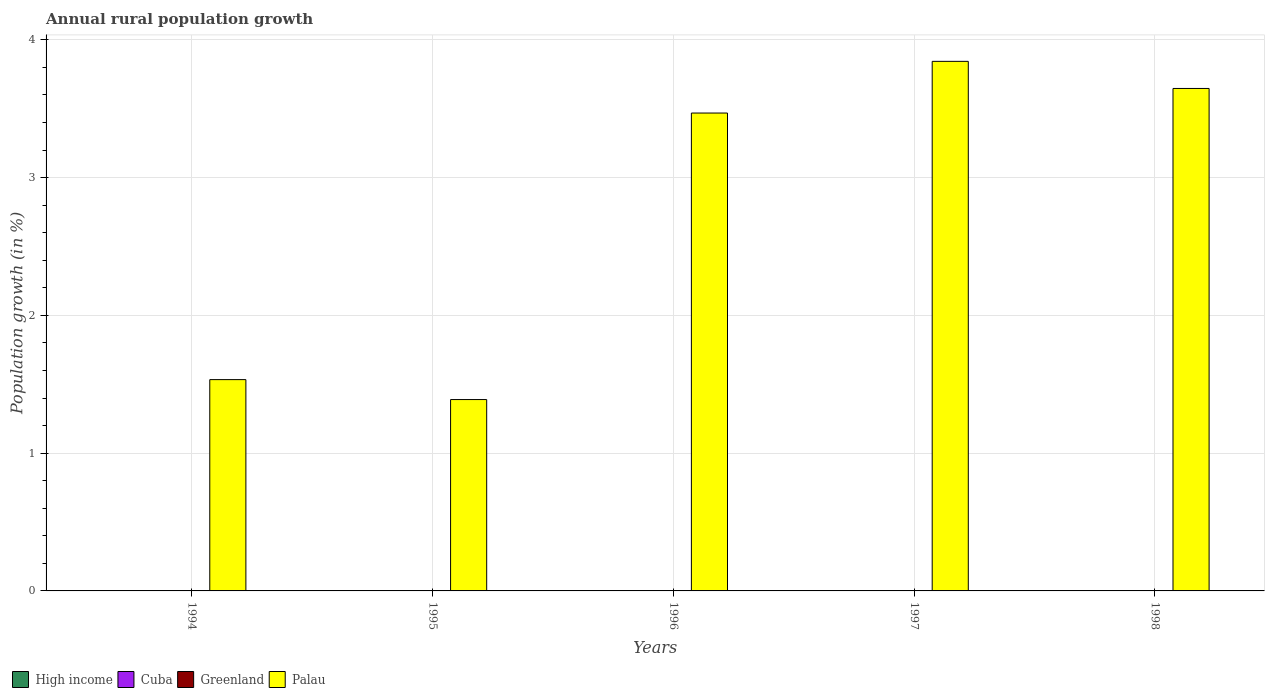How many different coloured bars are there?
Offer a terse response. 1. Are the number of bars on each tick of the X-axis equal?
Your response must be concise. Yes. How many bars are there on the 5th tick from the left?
Your answer should be very brief. 1. How many bars are there on the 2nd tick from the right?
Keep it short and to the point. 1. In how many cases, is the number of bars for a given year not equal to the number of legend labels?
Ensure brevity in your answer.  5. Across all years, what is the maximum percentage of rural population growth in Palau?
Give a very brief answer. 3.84. Across all years, what is the minimum percentage of rural population growth in Cuba?
Provide a short and direct response. 0. What is the total percentage of rural population growth in High income in the graph?
Your answer should be compact. 0. What is the difference between the percentage of rural population growth in Palau in 1994 and that in 1997?
Ensure brevity in your answer.  -2.31. What is the difference between the percentage of rural population growth in Palau in 1998 and the percentage of rural population growth in Cuba in 1996?
Offer a very short reply. 3.65. What is the average percentage of rural population growth in Palau per year?
Your answer should be very brief. 2.78. Is the percentage of rural population growth in Palau in 1994 less than that in 1995?
Offer a very short reply. No. What is the difference between the highest and the second highest percentage of rural population growth in Palau?
Give a very brief answer. 0.2. What is the difference between the highest and the lowest percentage of rural population growth in Palau?
Your response must be concise. 2.45. Are the values on the major ticks of Y-axis written in scientific E-notation?
Make the answer very short. No. Does the graph contain any zero values?
Offer a very short reply. Yes. What is the title of the graph?
Offer a terse response. Annual rural population growth. Does "Eritrea" appear as one of the legend labels in the graph?
Your response must be concise. No. What is the label or title of the X-axis?
Keep it short and to the point. Years. What is the label or title of the Y-axis?
Offer a terse response. Population growth (in %). What is the Population growth (in %) in High income in 1994?
Your response must be concise. 0. What is the Population growth (in %) of Cuba in 1994?
Provide a succinct answer. 0. What is the Population growth (in %) of Palau in 1994?
Ensure brevity in your answer.  1.53. What is the Population growth (in %) in High income in 1995?
Your answer should be very brief. 0. What is the Population growth (in %) of Cuba in 1995?
Ensure brevity in your answer.  0. What is the Population growth (in %) in Greenland in 1995?
Provide a short and direct response. 0. What is the Population growth (in %) in Palau in 1995?
Provide a succinct answer. 1.39. What is the Population growth (in %) of Cuba in 1996?
Provide a succinct answer. 0. What is the Population growth (in %) in Greenland in 1996?
Your response must be concise. 0. What is the Population growth (in %) in Palau in 1996?
Your answer should be compact. 3.47. What is the Population growth (in %) in High income in 1997?
Your answer should be compact. 0. What is the Population growth (in %) in Cuba in 1997?
Provide a succinct answer. 0. What is the Population growth (in %) in Greenland in 1997?
Offer a terse response. 0. What is the Population growth (in %) of Palau in 1997?
Give a very brief answer. 3.84. What is the Population growth (in %) in Cuba in 1998?
Provide a succinct answer. 0. What is the Population growth (in %) of Palau in 1998?
Provide a short and direct response. 3.65. Across all years, what is the maximum Population growth (in %) of Palau?
Your response must be concise. 3.84. Across all years, what is the minimum Population growth (in %) of Palau?
Offer a very short reply. 1.39. What is the total Population growth (in %) of Greenland in the graph?
Offer a terse response. 0. What is the total Population growth (in %) in Palau in the graph?
Provide a short and direct response. 13.88. What is the difference between the Population growth (in %) of Palau in 1994 and that in 1995?
Make the answer very short. 0.14. What is the difference between the Population growth (in %) in Palau in 1994 and that in 1996?
Give a very brief answer. -1.93. What is the difference between the Population growth (in %) of Palau in 1994 and that in 1997?
Keep it short and to the point. -2.31. What is the difference between the Population growth (in %) of Palau in 1994 and that in 1998?
Provide a short and direct response. -2.11. What is the difference between the Population growth (in %) in Palau in 1995 and that in 1996?
Make the answer very short. -2.08. What is the difference between the Population growth (in %) of Palau in 1995 and that in 1997?
Offer a very short reply. -2.45. What is the difference between the Population growth (in %) of Palau in 1995 and that in 1998?
Your answer should be very brief. -2.26. What is the difference between the Population growth (in %) in Palau in 1996 and that in 1997?
Make the answer very short. -0.38. What is the difference between the Population growth (in %) of Palau in 1996 and that in 1998?
Provide a succinct answer. -0.18. What is the difference between the Population growth (in %) in Palau in 1997 and that in 1998?
Keep it short and to the point. 0.2. What is the average Population growth (in %) of Greenland per year?
Your answer should be very brief. 0. What is the average Population growth (in %) of Palau per year?
Offer a very short reply. 2.78. What is the ratio of the Population growth (in %) in Palau in 1994 to that in 1995?
Give a very brief answer. 1.1. What is the ratio of the Population growth (in %) in Palau in 1994 to that in 1996?
Offer a terse response. 0.44. What is the ratio of the Population growth (in %) in Palau in 1994 to that in 1997?
Make the answer very short. 0.4. What is the ratio of the Population growth (in %) of Palau in 1994 to that in 1998?
Offer a very short reply. 0.42. What is the ratio of the Population growth (in %) of Palau in 1995 to that in 1996?
Keep it short and to the point. 0.4. What is the ratio of the Population growth (in %) in Palau in 1995 to that in 1997?
Provide a succinct answer. 0.36. What is the ratio of the Population growth (in %) in Palau in 1995 to that in 1998?
Your answer should be very brief. 0.38. What is the ratio of the Population growth (in %) in Palau in 1996 to that in 1997?
Provide a succinct answer. 0.9. What is the ratio of the Population growth (in %) of Palau in 1996 to that in 1998?
Provide a succinct answer. 0.95. What is the ratio of the Population growth (in %) of Palau in 1997 to that in 1998?
Provide a succinct answer. 1.05. What is the difference between the highest and the second highest Population growth (in %) in Palau?
Your answer should be very brief. 0.2. What is the difference between the highest and the lowest Population growth (in %) in Palau?
Your answer should be compact. 2.45. 